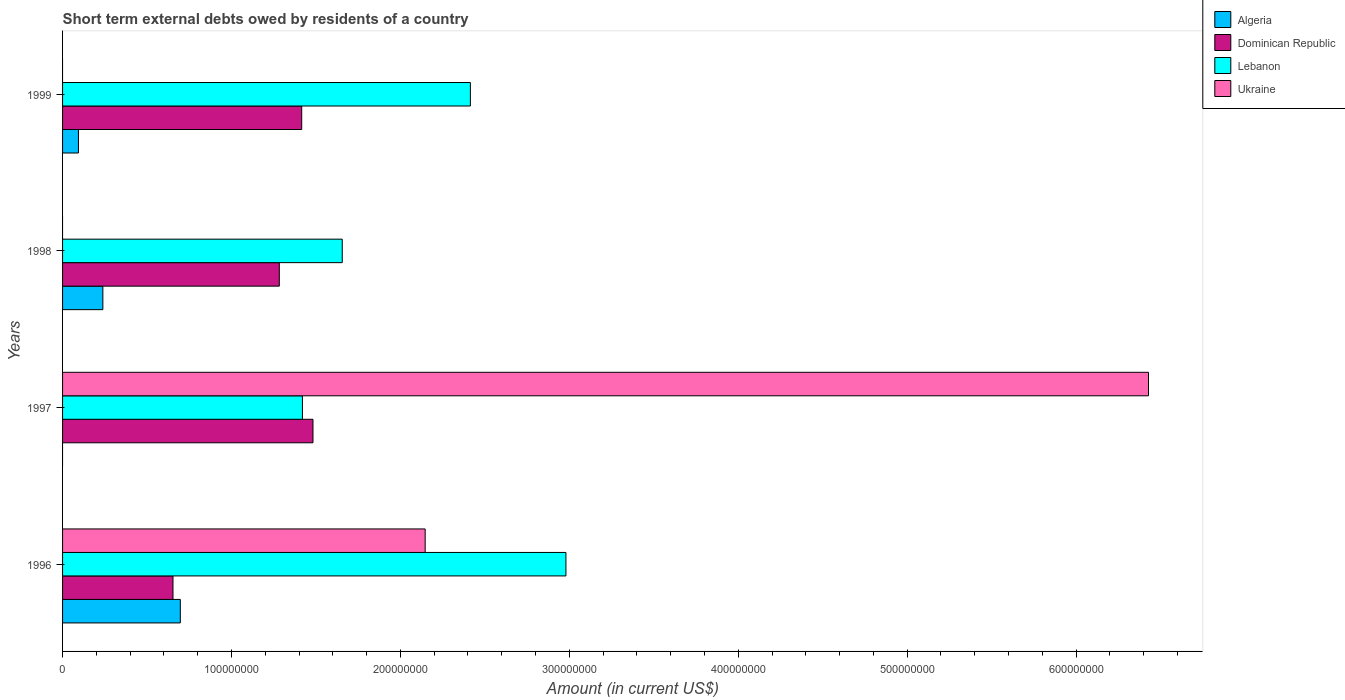How many groups of bars are there?
Keep it short and to the point. 4. Are the number of bars per tick equal to the number of legend labels?
Your answer should be compact. No. Are the number of bars on each tick of the Y-axis equal?
Give a very brief answer. No. How many bars are there on the 3rd tick from the top?
Make the answer very short. 3. How many bars are there on the 3rd tick from the bottom?
Keep it short and to the point. 3. In how many cases, is the number of bars for a given year not equal to the number of legend labels?
Provide a short and direct response. 3. What is the amount of short-term external debts owed by residents in Algeria in 1998?
Offer a very short reply. 2.38e+07. Across all years, what is the maximum amount of short-term external debts owed by residents in Algeria?
Provide a short and direct response. 6.97e+07. Across all years, what is the minimum amount of short-term external debts owed by residents in Algeria?
Offer a very short reply. 0. What is the total amount of short-term external debts owed by residents in Lebanon in the graph?
Ensure brevity in your answer.  8.47e+08. What is the difference between the amount of short-term external debts owed by residents in Algeria in 1998 and that in 1999?
Offer a very short reply. 1.44e+07. What is the difference between the amount of short-term external debts owed by residents in Algeria in 1997 and the amount of short-term external debts owed by residents in Dominican Republic in 1999?
Make the answer very short. -1.42e+08. What is the average amount of short-term external debts owed by residents in Lebanon per year?
Ensure brevity in your answer.  2.12e+08. In the year 1996, what is the difference between the amount of short-term external debts owed by residents in Algeria and amount of short-term external debts owed by residents in Lebanon?
Provide a succinct answer. -2.28e+08. What is the ratio of the amount of short-term external debts owed by residents in Lebanon in 1996 to that in 1998?
Give a very brief answer. 1.8. Is the amount of short-term external debts owed by residents in Algeria in 1996 less than that in 1998?
Your answer should be very brief. No. What is the difference between the highest and the second highest amount of short-term external debts owed by residents in Dominican Republic?
Make the answer very short. 6.68e+06. What is the difference between the highest and the lowest amount of short-term external debts owed by residents in Lebanon?
Offer a very short reply. 1.56e+08. Is it the case that in every year, the sum of the amount of short-term external debts owed by residents in Ukraine and amount of short-term external debts owed by residents in Lebanon is greater than the amount of short-term external debts owed by residents in Dominican Republic?
Give a very brief answer. Yes. Are all the bars in the graph horizontal?
Ensure brevity in your answer.  Yes. What is the difference between two consecutive major ticks on the X-axis?
Your response must be concise. 1.00e+08. Are the values on the major ticks of X-axis written in scientific E-notation?
Keep it short and to the point. No. How many legend labels are there?
Keep it short and to the point. 4. How are the legend labels stacked?
Provide a succinct answer. Vertical. What is the title of the graph?
Offer a terse response. Short term external debts owed by residents of a country. Does "Montenegro" appear as one of the legend labels in the graph?
Your answer should be very brief. No. What is the label or title of the X-axis?
Offer a very short reply. Amount (in current US$). What is the label or title of the Y-axis?
Provide a succinct answer. Years. What is the Amount (in current US$) of Algeria in 1996?
Your answer should be very brief. 6.97e+07. What is the Amount (in current US$) in Dominican Republic in 1996?
Your response must be concise. 6.54e+07. What is the Amount (in current US$) in Lebanon in 1996?
Offer a very short reply. 2.98e+08. What is the Amount (in current US$) of Ukraine in 1996?
Your response must be concise. 2.15e+08. What is the Amount (in current US$) of Algeria in 1997?
Give a very brief answer. 0. What is the Amount (in current US$) of Dominican Republic in 1997?
Offer a very short reply. 1.48e+08. What is the Amount (in current US$) of Lebanon in 1997?
Offer a very short reply. 1.42e+08. What is the Amount (in current US$) of Ukraine in 1997?
Keep it short and to the point. 6.43e+08. What is the Amount (in current US$) of Algeria in 1998?
Your response must be concise. 2.38e+07. What is the Amount (in current US$) of Dominican Republic in 1998?
Provide a short and direct response. 1.28e+08. What is the Amount (in current US$) of Lebanon in 1998?
Keep it short and to the point. 1.66e+08. What is the Amount (in current US$) of Algeria in 1999?
Offer a very short reply. 9.40e+06. What is the Amount (in current US$) of Dominican Republic in 1999?
Provide a short and direct response. 1.42e+08. What is the Amount (in current US$) in Lebanon in 1999?
Your answer should be compact. 2.41e+08. Across all years, what is the maximum Amount (in current US$) of Algeria?
Keep it short and to the point. 6.97e+07. Across all years, what is the maximum Amount (in current US$) of Dominican Republic?
Provide a short and direct response. 1.48e+08. Across all years, what is the maximum Amount (in current US$) of Lebanon?
Your response must be concise. 2.98e+08. Across all years, what is the maximum Amount (in current US$) of Ukraine?
Ensure brevity in your answer.  6.43e+08. Across all years, what is the minimum Amount (in current US$) of Dominican Republic?
Offer a very short reply. 6.54e+07. Across all years, what is the minimum Amount (in current US$) of Lebanon?
Your answer should be very brief. 1.42e+08. What is the total Amount (in current US$) in Algeria in the graph?
Offer a very short reply. 1.03e+08. What is the total Amount (in current US$) in Dominican Republic in the graph?
Your answer should be very brief. 4.84e+08. What is the total Amount (in current US$) in Lebanon in the graph?
Ensure brevity in your answer.  8.47e+08. What is the total Amount (in current US$) of Ukraine in the graph?
Your answer should be compact. 8.58e+08. What is the difference between the Amount (in current US$) in Dominican Republic in 1996 and that in 1997?
Your response must be concise. -8.29e+07. What is the difference between the Amount (in current US$) of Lebanon in 1996 and that in 1997?
Make the answer very short. 1.56e+08. What is the difference between the Amount (in current US$) in Ukraine in 1996 and that in 1997?
Ensure brevity in your answer.  -4.28e+08. What is the difference between the Amount (in current US$) in Algeria in 1996 and that in 1998?
Offer a very short reply. 4.59e+07. What is the difference between the Amount (in current US$) in Dominican Republic in 1996 and that in 1998?
Your answer should be very brief. -6.29e+07. What is the difference between the Amount (in current US$) in Lebanon in 1996 and that in 1998?
Make the answer very short. 1.32e+08. What is the difference between the Amount (in current US$) in Algeria in 1996 and that in 1999?
Give a very brief answer. 6.03e+07. What is the difference between the Amount (in current US$) in Dominican Republic in 1996 and that in 1999?
Your answer should be very brief. -7.62e+07. What is the difference between the Amount (in current US$) in Lebanon in 1996 and that in 1999?
Keep it short and to the point. 5.66e+07. What is the difference between the Amount (in current US$) in Dominican Republic in 1997 and that in 1998?
Your answer should be compact. 1.99e+07. What is the difference between the Amount (in current US$) in Lebanon in 1997 and that in 1998?
Your answer should be compact. -2.36e+07. What is the difference between the Amount (in current US$) in Dominican Republic in 1997 and that in 1999?
Give a very brief answer. 6.68e+06. What is the difference between the Amount (in current US$) of Lebanon in 1997 and that in 1999?
Ensure brevity in your answer.  -9.94e+07. What is the difference between the Amount (in current US$) of Algeria in 1998 and that in 1999?
Your answer should be very brief. 1.44e+07. What is the difference between the Amount (in current US$) of Dominican Republic in 1998 and that in 1999?
Your answer should be compact. -1.33e+07. What is the difference between the Amount (in current US$) in Lebanon in 1998 and that in 1999?
Your response must be concise. -7.59e+07. What is the difference between the Amount (in current US$) in Algeria in 1996 and the Amount (in current US$) in Dominican Republic in 1997?
Give a very brief answer. -7.85e+07. What is the difference between the Amount (in current US$) in Algeria in 1996 and the Amount (in current US$) in Lebanon in 1997?
Keep it short and to the point. -7.23e+07. What is the difference between the Amount (in current US$) in Algeria in 1996 and the Amount (in current US$) in Ukraine in 1997?
Keep it short and to the point. -5.73e+08. What is the difference between the Amount (in current US$) in Dominican Republic in 1996 and the Amount (in current US$) in Lebanon in 1997?
Provide a short and direct response. -7.66e+07. What is the difference between the Amount (in current US$) in Dominican Republic in 1996 and the Amount (in current US$) in Ukraine in 1997?
Your answer should be compact. -5.78e+08. What is the difference between the Amount (in current US$) of Lebanon in 1996 and the Amount (in current US$) of Ukraine in 1997?
Give a very brief answer. -3.45e+08. What is the difference between the Amount (in current US$) in Algeria in 1996 and the Amount (in current US$) in Dominican Republic in 1998?
Keep it short and to the point. -5.86e+07. What is the difference between the Amount (in current US$) in Algeria in 1996 and the Amount (in current US$) in Lebanon in 1998?
Give a very brief answer. -9.59e+07. What is the difference between the Amount (in current US$) of Dominican Republic in 1996 and the Amount (in current US$) of Lebanon in 1998?
Give a very brief answer. -1.00e+08. What is the difference between the Amount (in current US$) of Algeria in 1996 and the Amount (in current US$) of Dominican Republic in 1999?
Provide a succinct answer. -7.19e+07. What is the difference between the Amount (in current US$) of Algeria in 1996 and the Amount (in current US$) of Lebanon in 1999?
Keep it short and to the point. -1.72e+08. What is the difference between the Amount (in current US$) in Dominican Republic in 1996 and the Amount (in current US$) in Lebanon in 1999?
Provide a short and direct response. -1.76e+08. What is the difference between the Amount (in current US$) in Dominican Republic in 1997 and the Amount (in current US$) in Lebanon in 1998?
Make the answer very short. -1.73e+07. What is the difference between the Amount (in current US$) of Dominican Republic in 1997 and the Amount (in current US$) of Lebanon in 1999?
Keep it short and to the point. -9.32e+07. What is the difference between the Amount (in current US$) in Algeria in 1998 and the Amount (in current US$) in Dominican Republic in 1999?
Keep it short and to the point. -1.18e+08. What is the difference between the Amount (in current US$) in Algeria in 1998 and the Amount (in current US$) in Lebanon in 1999?
Make the answer very short. -2.18e+08. What is the difference between the Amount (in current US$) of Dominican Republic in 1998 and the Amount (in current US$) of Lebanon in 1999?
Your response must be concise. -1.13e+08. What is the average Amount (in current US$) of Algeria per year?
Keep it short and to the point. 2.57e+07. What is the average Amount (in current US$) of Dominican Republic per year?
Your answer should be compact. 1.21e+08. What is the average Amount (in current US$) of Lebanon per year?
Give a very brief answer. 2.12e+08. What is the average Amount (in current US$) in Ukraine per year?
Your response must be concise. 2.14e+08. In the year 1996, what is the difference between the Amount (in current US$) in Algeria and Amount (in current US$) in Dominican Republic?
Your answer should be very brief. 4.34e+06. In the year 1996, what is the difference between the Amount (in current US$) in Algeria and Amount (in current US$) in Lebanon?
Your answer should be compact. -2.28e+08. In the year 1996, what is the difference between the Amount (in current US$) in Algeria and Amount (in current US$) in Ukraine?
Give a very brief answer. -1.45e+08. In the year 1996, what is the difference between the Amount (in current US$) in Dominican Republic and Amount (in current US$) in Lebanon?
Offer a very short reply. -2.33e+08. In the year 1996, what is the difference between the Amount (in current US$) of Dominican Republic and Amount (in current US$) of Ukraine?
Your answer should be compact. -1.49e+08. In the year 1996, what is the difference between the Amount (in current US$) in Lebanon and Amount (in current US$) in Ukraine?
Your answer should be compact. 8.33e+07. In the year 1997, what is the difference between the Amount (in current US$) of Dominican Republic and Amount (in current US$) of Lebanon?
Give a very brief answer. 6.25e+06. In the year 1997, what is the difference between the Amount (in current US$) of Dominican Republic and Amount (in current US$) of Ukraine?
Your answer should be very brief. -4.95e+08. In the year 1997, what is the difference between the Amount (in current US$) of Lebanon and Amount (in current US$) of Ukraine?
Your answer should be compact. -5.01e+08. In the year 1998, what is the difference between the Amount (in current US$) of Algeria and Amount (in current US$) of Dominican Republic?
Offer a very short reply. -1.04e+08. In the year 1998, what is the difference between the Amount (in current US$) of Algeria and Amount (in current US$) of Lebanon?
Give a very brief answer. -1.42e+08. In the year 1998, what is the difference between the Amount (in current US$) of Dominican Republic and Amount (in current US$) of Lebanon?
Keep it short and to the point. -3.73e+07. In the year 1999, what is the difference between the Amount (in current US$) of Algeria and Amount (in current US$) of Dominican Republic?
Provide a succinct answer. -1.32e+08. In the year 1999, what is the difference between the Amount (in current US$) in Algeria and Amount (in current US$) in Lebanon?
Provide a short and direct response. -2.32e+08. In the year 1999, what is the difference between the Amount (in current US$) in Dominican Republic and Amount (in current US$) in Lebanon?
Your response must be concise. -9.99e+07. What is the ratio of the Amount (in current US$) of Dominican Republic in 1996 to that in 1997?
Make the answer very short. 0.44. What is the ratio of the Amount (in current US$) in Lebanon in 1996 to that in 1997?
Keep it short and to the point. 2.1. What is the ratio of the Amount (in current US$) of Ukraine in 1996 to that in 1997?
Keep it short and to the point. 0.33. What is the ratio of the Amount (in current US$) in Algeria in 1996 to that in 1998?
Offer a very short reply. 2.92. What is the ratio of the Amount (in current US$) in Dominican Republic in 1996 to that in 1998?
Provide a succinct answer. 0.51. What is the ratio of the Amount (in current US$) in Lebanon in 1996 to that in 1998?
Offer a terse response. 1.8. What is the ratio of the Amount (in current US$) of Algeria in 1996 to that in 1999?
Your answer should be compact. 7.41. What is the ratio of the Amount (in current US$) in Dominican Republic in 1996 to that in 1999?
Your answer should be compact. 0.46. What is the ratio of the Amount (in current US$) in Lebanon in 1996 to that in 1999?
Provide a succinct answer. 1.23. What is the ratio of the Amount (in current US$) in Dominican Republic in 1997 to that in 1998?
Keep it short and to the point. 1.16. What is the ratio of the Amount (in current US$) in Lebanon in 1997 to that in 1998?
Offer a very short reply. 0.86. What is the ratio of the Amount (in current US$) in Dominican Republic in 1997 to that in 1999?
Your answer should be compact. 1.05. What is the ratio of the Amount (in current US$) in Lebanon in 1997 to that in 1999?
Provide a short and direct response. 0.59. What is the ratio of the Amount (in current US$) of Algeria in 1998 to that in 1999?
Ensure brevity in your answer.  2.54. What is the ratio of the Amount (in current US$) of Dominican Republic in 1998 to that in 1999?
Give a very brief answer. 0.91. What is the ratio of the Amount (in current US$) in Lebanon in 1998 to that in 1999?
Make the answer very short. 0.69. What is the difference between the highest and the second highest Amount (in current US$) of Algeria?
Your answer should be very brief. 4.59e+07. What is the difference between the highest and the second highest Amount (in current US$) in Dominican Republic?
Your response must be concise. 6.68e+06. What is the difference between the highest and the second highest Amount (in current US$) in Lebanon?
Give a very brief answer. 5.66e+07. What is the difference between the highest and the lowest Amount (in current US$) of Algeria?
Provide a short and direct response. 6.97e+07. What is the difference between the highest and the lowest Amount (in current US$) of Dominican Republic?
Make the answer very short. 8.29e+07. What is the difference between the highest and the lowest Amount (in current US$) in Lebanon?
Give a very brief answer. 1.56e+08. What is the difference between the highest and the lowest Amount (in current US$) in Ukraine?
Offer a very short reply. 6.43e+08. 